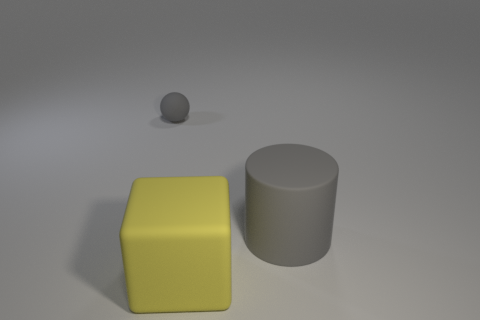What shapes can you identify in the image? The image displays three distinct shapes. There's a large yellow cube, a smaller gray sphere slightly behind it, and a larger gray cylinder to the right. 